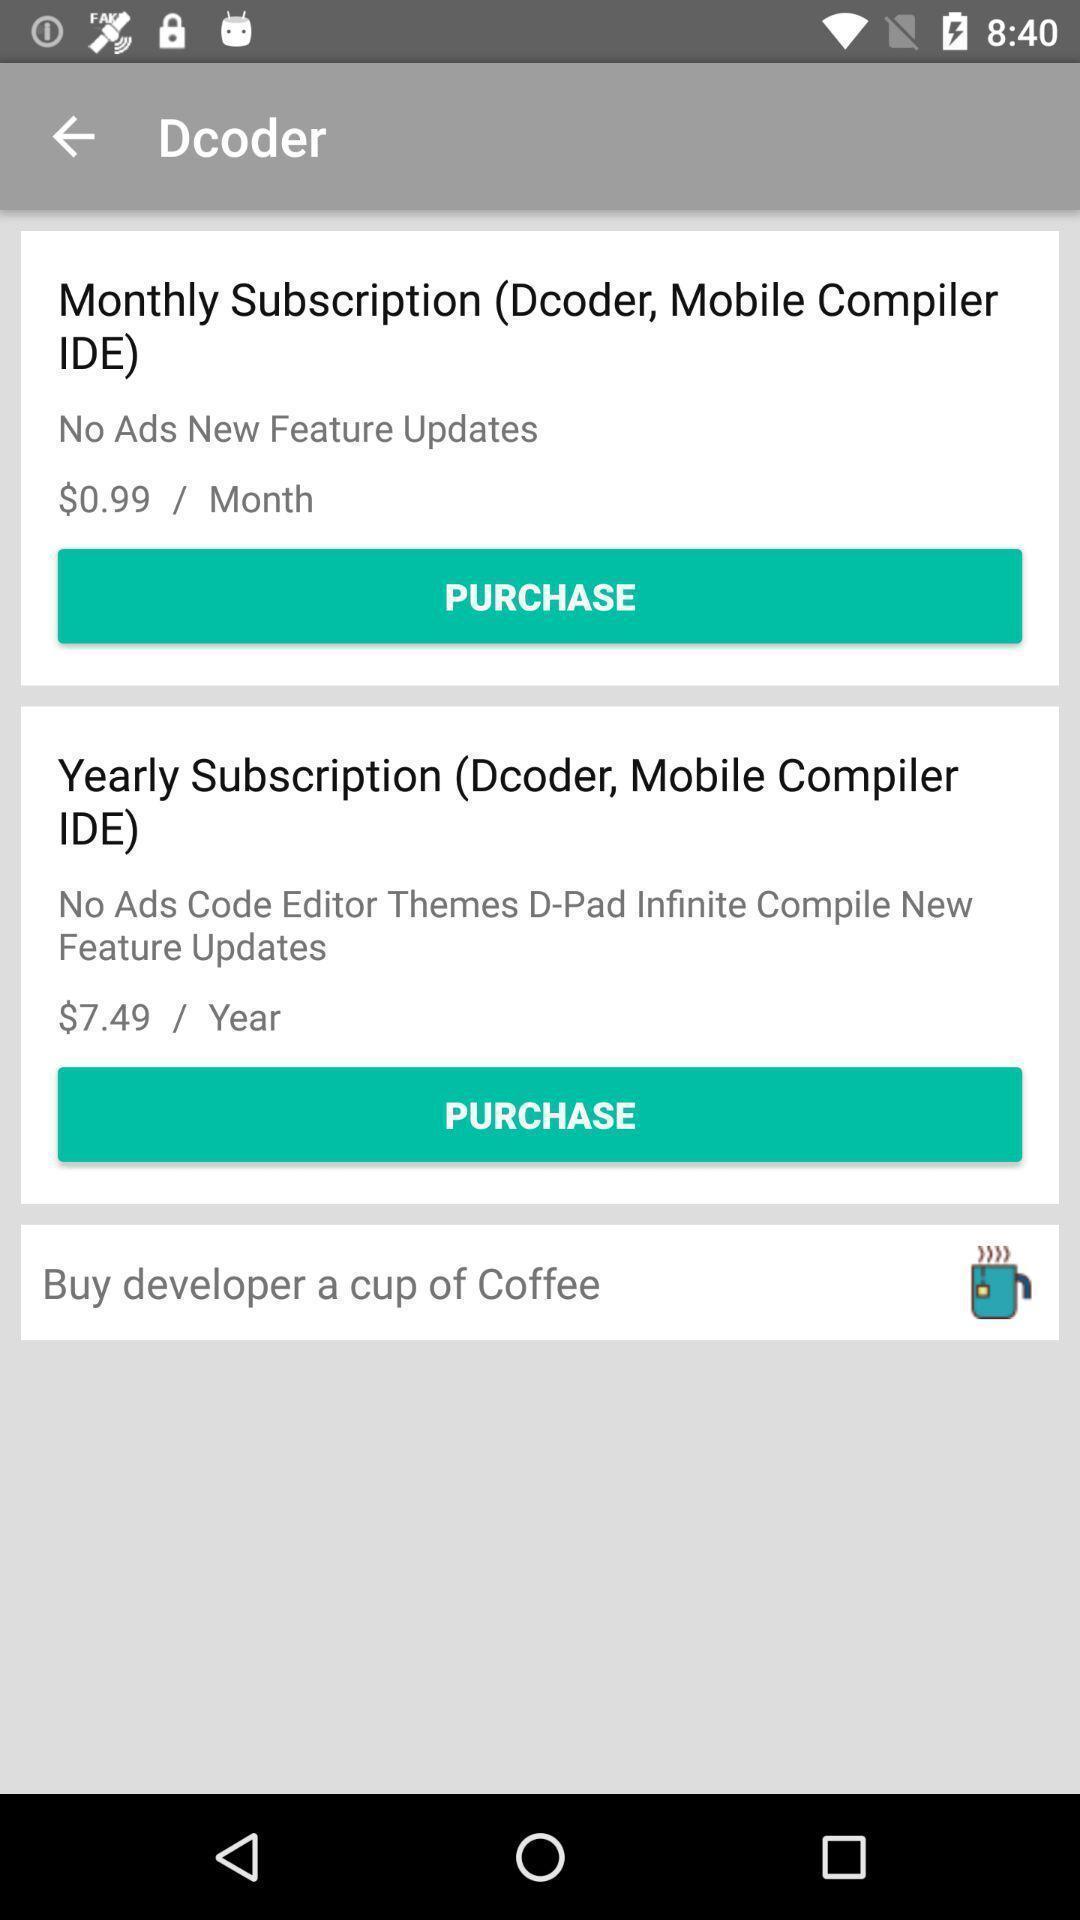Provide a detailed account of this screenshot. Screen displaying multiple subscription options with price. 